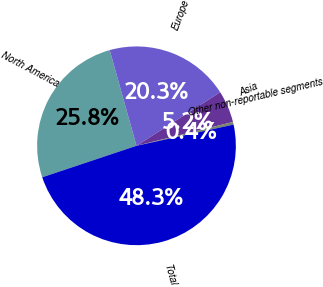Convert chart. <chart><loc_0><loc_0><loc_500><loc_500><pie_chart><fcel>North America<fcel>Europe<fcel>Asia<fcel>Other non-reportable segments<fcel>Total<nl><fcel>25.79%<fcel>20.28%<fcel>5.21%<fcel>0.43%<fcel>48.29%<nl></chart> 